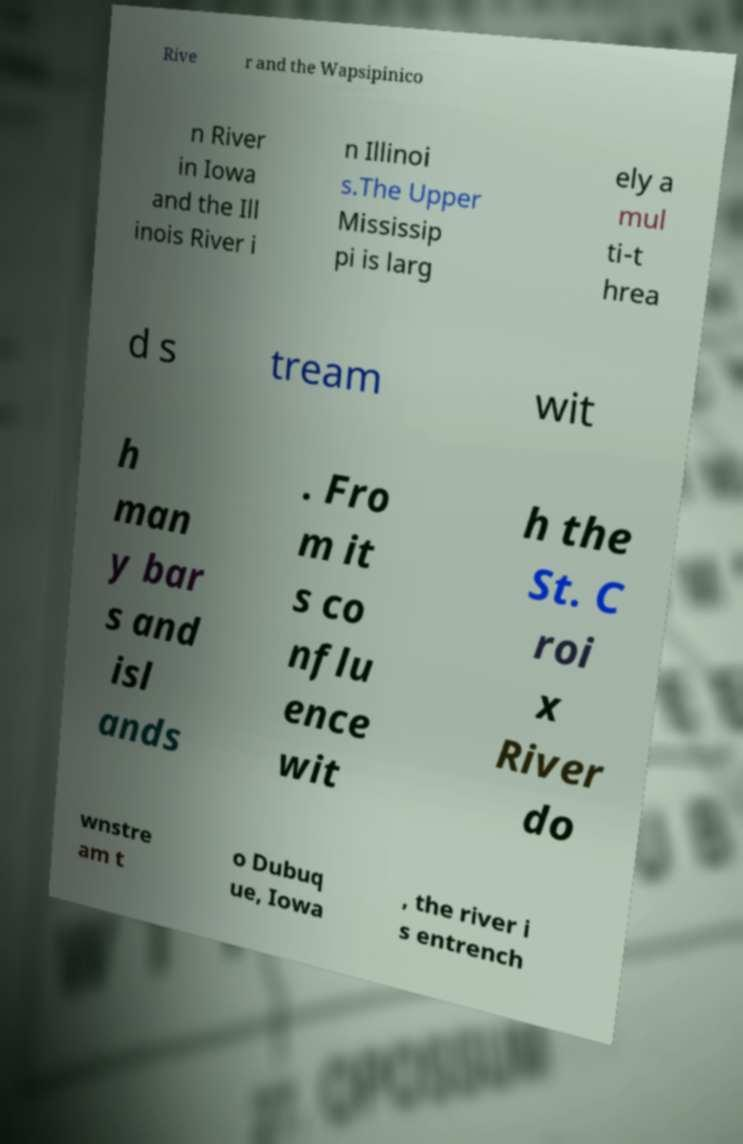What messages or text are displayed in this image? I need them in a readable, typed format. Rive r and the Wapsipinico n River in Iowa and the Ill inois River i n Illinoi s.The Upper Mississip pi is larg ely a mul ti-t hrea d s tream wit h man y bar s and isl ands . Fro m it s co nflu ence wit h the St. C roi x River do wnstre am t o Dubuq ue, Iowa , the river i s entrench 